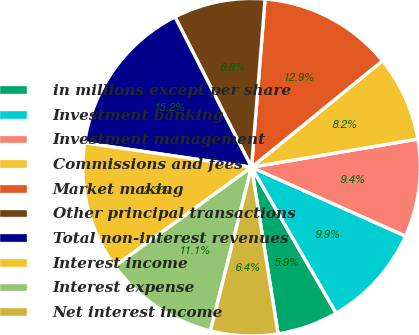<chart> <loc_0><loc_0><loc_500><loc_500><pie_chart><fcel>in millions except per share<fcel>Investment banking<fcel>Investment management<fcel>Commissions and fees<fcel>Market making<fcel>Other principal transactions<fcel>Total non-interest revenues<fcel>Interest income<fcel>Interest expense<fcel>Net interest income<nl><fcel>5.85%<fcel>9.94%<fcel>9.36%<fcel>8.19%<fcel>12.86%<fcel>8.77%<fcel>15.2%<fcel>12.28%<fcel>11.11%<fcel>6.43%<nl></chart> 